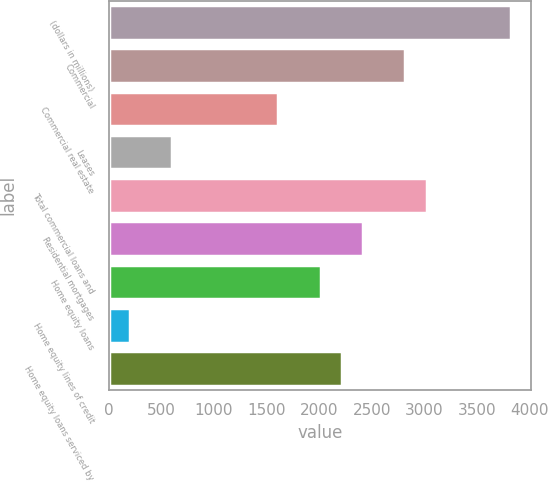<chart> <loc_0><loc_0><loc_500><loc_500><bar_chart><fcel>(dollars in millions)<fcel>Commercial<fcel>Commercial real estate<fcel>Leases<fcel>Total commercial loans and<fcel>Residential mortgages<fcel>Home equity loans<fcel>Home equity lines of credit<fcel>Home equity loans serviced by<nl><fcel>3823.8<fcel>2817.8<fcel>1610.6<fcel>604.6<fcel>3019<fcel>2415.4<fcel>2013<fcel>202.2<fcel>2214.2<nl></chart> 